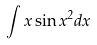Convert formula to latex. <formula><loc_0><loc_0><loc_500><loc_500>\int x \sin x ^ { 2 } d x</formula> 